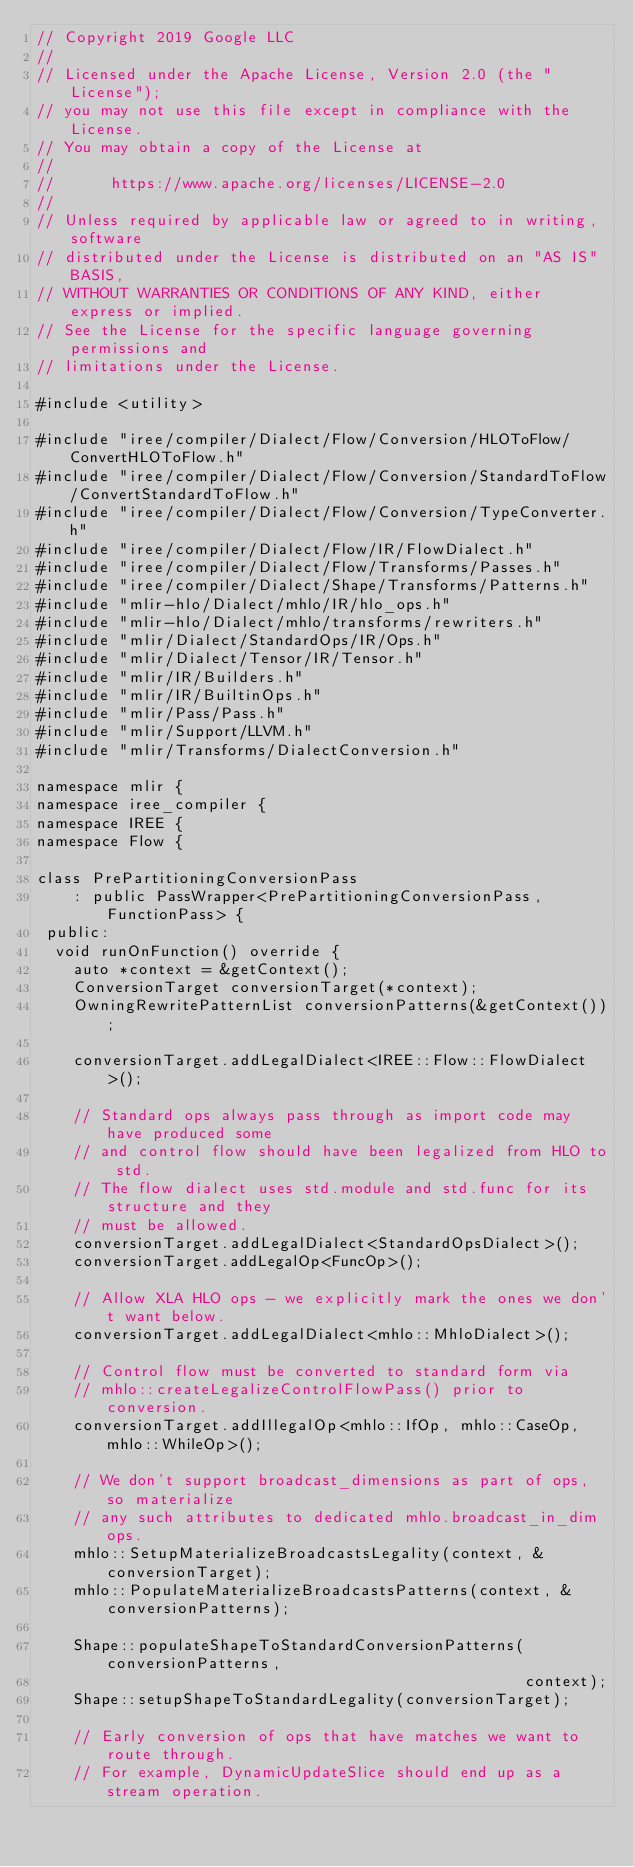Convert code to text. <code><loc_0><loc_0><loc_500><loc_500><_C++_>// Copyright 2019 Google LLC
//
// Licensed under the Apache License, Version 2.0 (the "License");
// you may not use this file except in compliance with the License.
// You may obtain a copy of the License at
//
//      https://www.apache.org/licenses/LICENSE-2.0
//
// Unless required by applicable law or agreed to in writing, software
// distributed under the License is distributed on an "AS IS" BASIS,
// WITHOUT WARRANTIES OR CONDITIONS OF ANY KIND, either express or implied.
// See the License for the specific language governing permissions and
// limitations under the License.

#include <utility>

#include "iree/compiler/Dialect/Flow/Conversion/HLOToFlow/ConvertHLOToFlow.h"
#include "iree/compiler/Dialect/Flow/Conversion/StandardToFlow/ConvertStandardToFlow.h"
#include "iree/compiler/Dialect/Flow/Conversion/TypeConverter.h"
#include "iree/compiler/Dialect/Flow/IR/FlowDialect.h"
#include "iree/compiler/Dialect/Flow/Transforms/Passes.h"
#include "iree/compiler/Dialect/Shape/Transforms/Patterns.h"
#include "mlir-hlo/Dialect/mhlo/IR/hlo_ops.h"
#include "mlir-hlo/Dialect/mhlo/transforms/rewriters.h"
#include "mlir/Dialect/StandardOps/IR/Ops.h"
#include "mlir/Dialect/Tensor/IR/Tensor.h"
#include "mlir/IR/Builders.h"
#include "mlir/IR/BuiltinOps.h"
#include "mlir/Pass/Pass.h"
#include "mlir/Support/LLVM.h"
#include "mlir/Transforms/DialectConversion.h"

namespace mlir {
namespace iree_compiler {
namespace IREE {
namespace Flow {

class PrePartitioningConversionPass
    : public PassWrapper<PrePartitioningConversionPass, FunctionPass> {
 public:
  void runOnFunction() override {
    auto *context = &getContext();
    ConversionTarget conversionTarget(*context);
    OwningRewritePatternList conversionPatterns(&getContext());

    conversionTarget.addLegalDialect<IREE::Flow::FlowDialect>();

    // Standard ops always pass through as import code may have produced some
    // and control flow should have been legalized from HLO to std.
    // The flow dialect uses std.module and std.func for its structure and they
    // must be allowed.
    conversionTarget.addLegalDialect<StandardOpsDialect>();
    conversionTarget.addLegalOp<FuncOp>();

    // Allow XLA HLO ops - we explicitly mark the ones we don't want below.
    conversionTarget.addLegalDialect<mhlo::MhloDialect>();

    // Control flow must be converted to standard form via
    // mhlo::createLegalizeControlFlowPass() prior to conversion.
    conversionTarget.addIllegalOp<mhlo::IfOp, mhlo::CaseOp, mhlo::WhileOp>();

    // We don't support broadcast_dimensions as part of ops, so materialize
    // any such attributes to dedicated mhlo.broadcast_in_dim ops.
    mhlo::SetupMaterializeBroadcastsLegality(context, &conversionTarget);
    mhlo::PopulateMaterializeBroadcastsPatterns(context, &conversionPatterns);

    Shape::populateShapeToStandardConversionPatterns(conversionPatterns,
                                                     context);
    Shape::setupShapeToStandardLegality(conversionTarget);

    // Early conversion of ops that have matches we want to route through.
    // For example, DynamicUpdateSlice should end up as a stream operation.</code> 